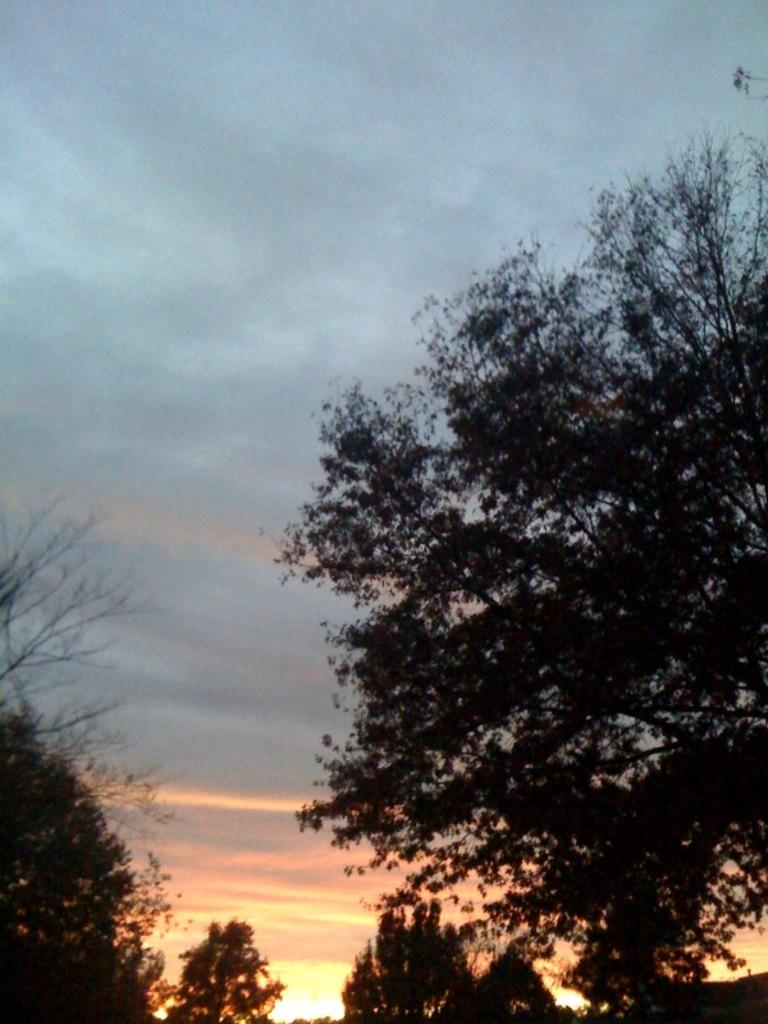What type of vegetation can be seen in the image? There are trees in the image. What part of the natural environment is visible in the image? The sky is visible in the image. What colors can be seen in the sky in the image? The sky has blue, black, orange, and yellow colors. What type of disease is affecting the trees in the image? There is no indication of any disease affecting the trees in the image. What authority figure can be seen in the image? There is no authority figure present in the image. 